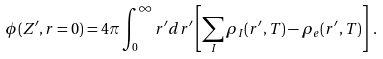Convert formula to latex. <formula><loc_0><loc_0><loc_500><loc_500>\phi ( Z ^ { \prime } , r = 0 ) = 4 \pi \int _ { 0 } ^ { \infty } r ^ { \prime } d r ^ { \prime } \left [ \sum _ { I } \rho _ { I } ( r ^ { \prime } , T ) - \rho _ { e } ( r ^ { \prime } , T ) \right ] \, .</formula> 